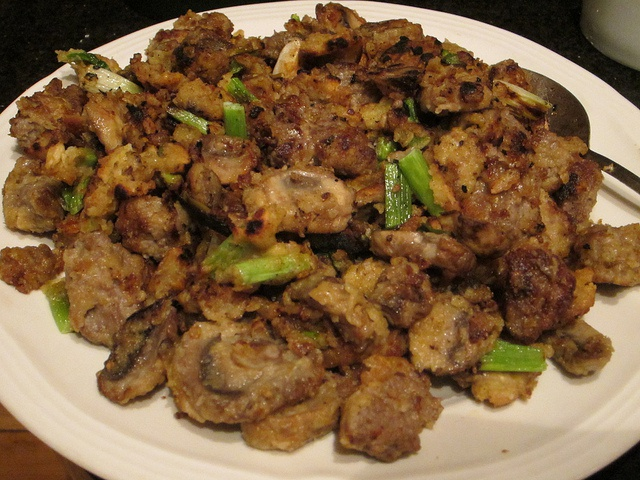Describe the objects in this image and their specific colors. I can see fork in black, maroon, and olive tones and spoon in black, maroon, and olive tones in this image. 